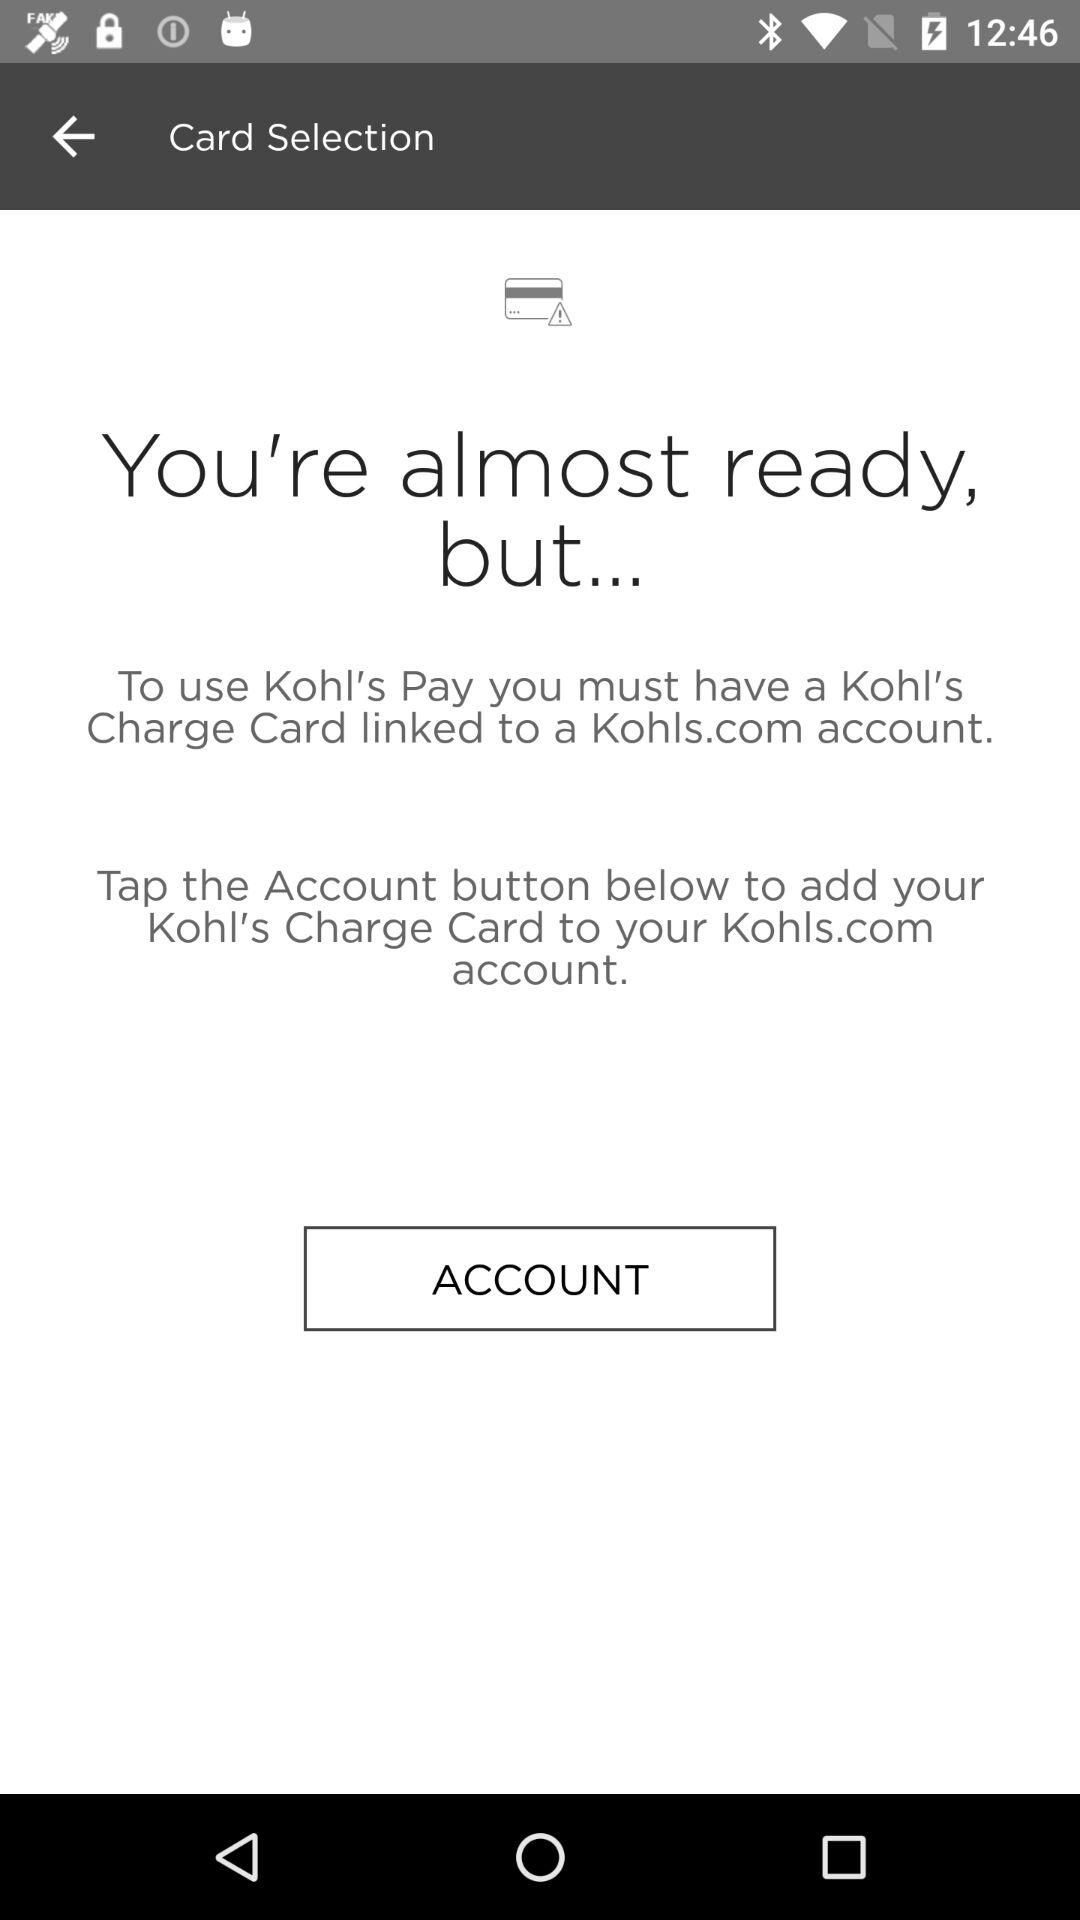How many sentences are there in the text on this screen?
Answer the question using a single word or phrase. 3 